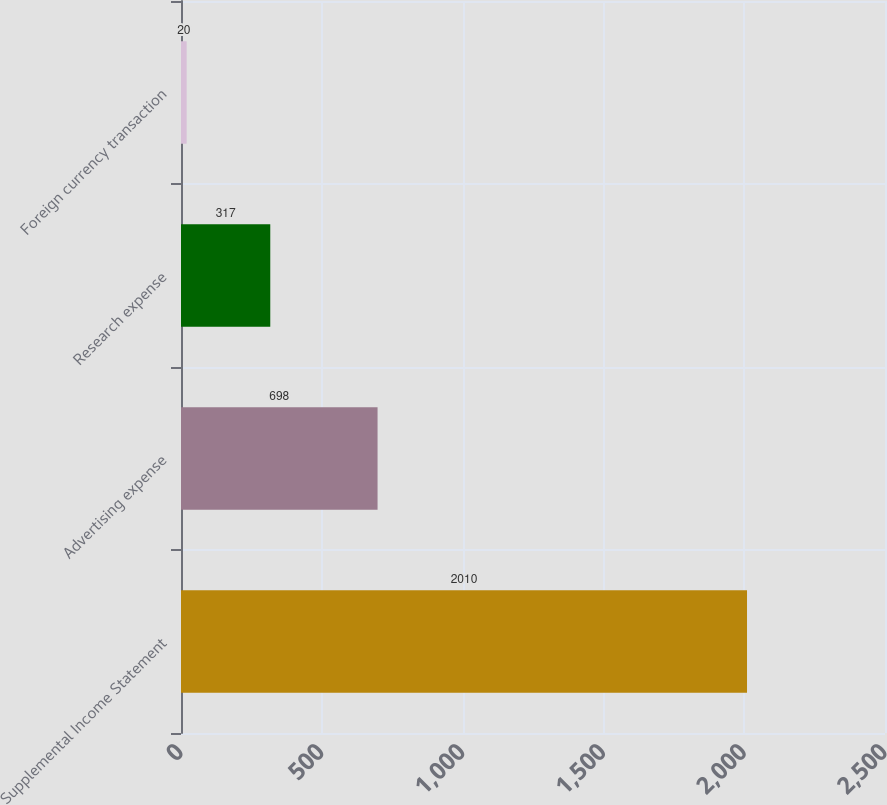Convert chart. <chart><loc_0><loc_0><loc_500><loc_500><bar_chart><fcel>Supplemental Income Statement<fcel>Advertising expense<fcel>Research expense<fcel>Foreign currency transaction<nl><fcel>2010<fcel>698<fcel>317<fcel>20<nl></chart> 